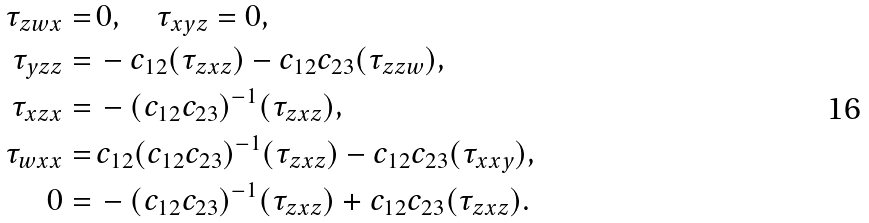<formula> <loc_0><loc_0><loc_500><loc_500>\tau _ { z w x } = & \, 0 , \quad \tau _ { x y z } = 0 , \\ \tau _ { y z z } = & \, - c _ { 1 2 } ( \tau _ { z x z } ) - c _ { 1 2 } c _ { 2 3 } ( \tau _ { z z w } ) , \\ \tau _ { x z x } = & \, - ( c _ { 1 2 } c _ { 2 3 } ) ^ { - 1 } ( \tau _ { z x z } ) , \\ \tau _ { w x x } = & \, c _ { 1 2 } ( c _ { 1 2 } c _ { 2 3 } ) ^ { - 1 } ( \tau _ { z x z } ) - c _ { 1 2 } c _ { 2 3 } ( \tau _ { x x y } ) , \\ 0 = & \, - ( c _ { 1 2 } c _ { 2 3 } ) ^ { - 1 } ( \tau _ { z x z } ) + c _ { 1 2 } c _ { 2 3 } ( \tau _ { z x z } ) .</formula> 